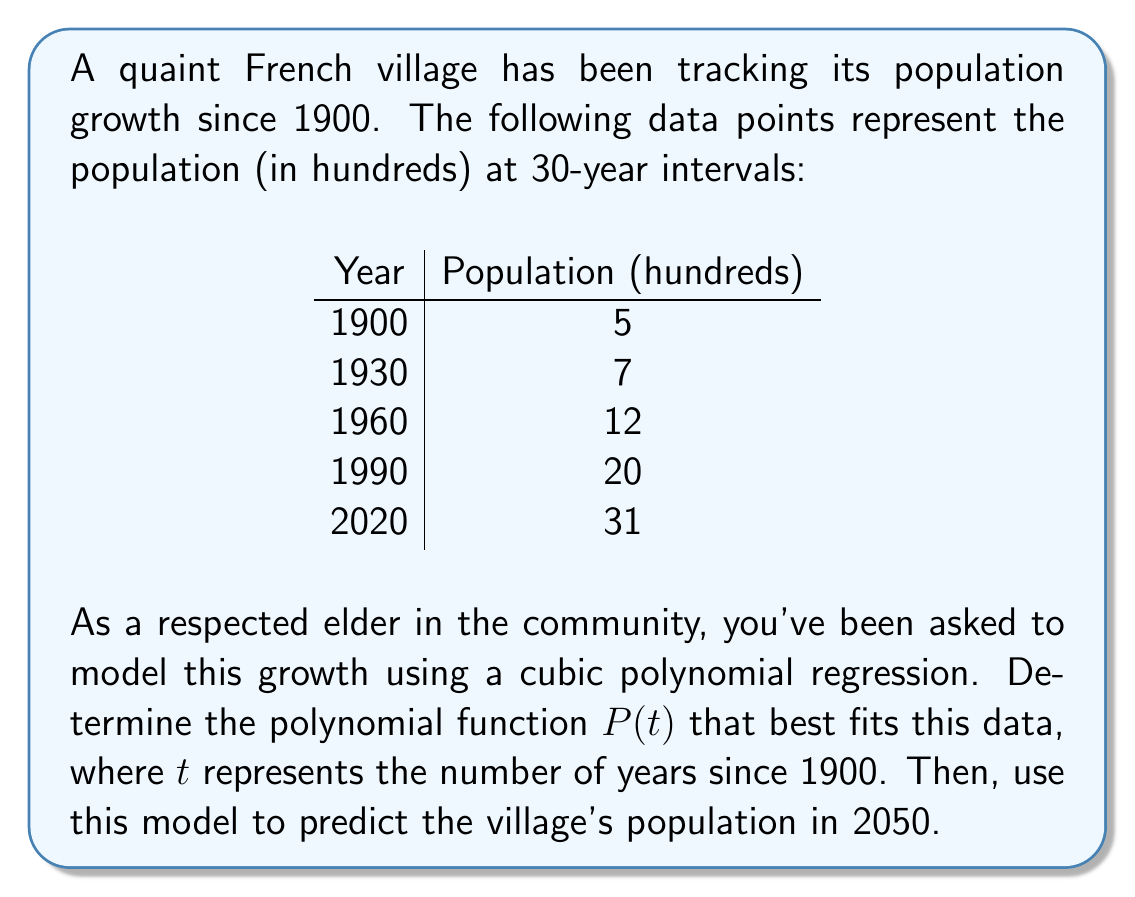Teach me how to tackle this problem. To model this data with a cubic polynomial regression, we'll use the function:

$P(t) = at^3 + bt^2 + ct + d$

Where $t$ is the number of years since 1900.

Step 1: Set up the system of equations using the given data points:
$$\begin{align}
5 &= a(0)^3 + b(0)^2 + c(0) + d \\
7 &= a(30)^3 + b(30)^2 + c(30) + d \\
12 &= a(60)^3 + b(60)^2 + c(60) + d \\
20 &= a(90)^3 + b(90)^2 + c(90) + d \\
31 &= a(120)^3 + b(120)^2 + c(120) + d
\end{align}$$

Step 2: Simplify the equations:
$$\begin{align}
5 &= d \\
7 &= 27000a + 900b + 30c + d \\
12 &= 216000a + 3600b + 60c + d \\
20 &= 729000a + 8100b + 90c + d \\
31 &= 1728000a + 14400b + 120c + d
\end{align}$$

Step 3: Solve this system of equations using a computer algebra system or matrix operations. The result is:

$a \approx 0.0000006481$
$b \approx 0.0001389$
$c \approx 0.0333333$
$d = 5$

Step 4: Write the polynomial function:

$P(t) \approx 0.0000006481t^3 + 0.0001389t^2 + 0.0333333t + 5$

Step 5: To predict the population in 2050, calculate $P(150)$:

$P(150) \approx 0.0000006481(150)^3 + 0.0001389(150)^2 + 0.0333333(150) + 5$
$\approx 45.68$

Step 6: Convert the result back to actual population (remember we were working in hundreds):

$45.68 \times 100 \approx 4,568$
Answer: The cubic polynomial function that models the village's population growth is:

$P(t) \approx 0.0000006481t^3 + 0.0001389t^2 + 0.0333333t + 5$

The predicted population of the village in 2050 is approximately 4,568 people. 